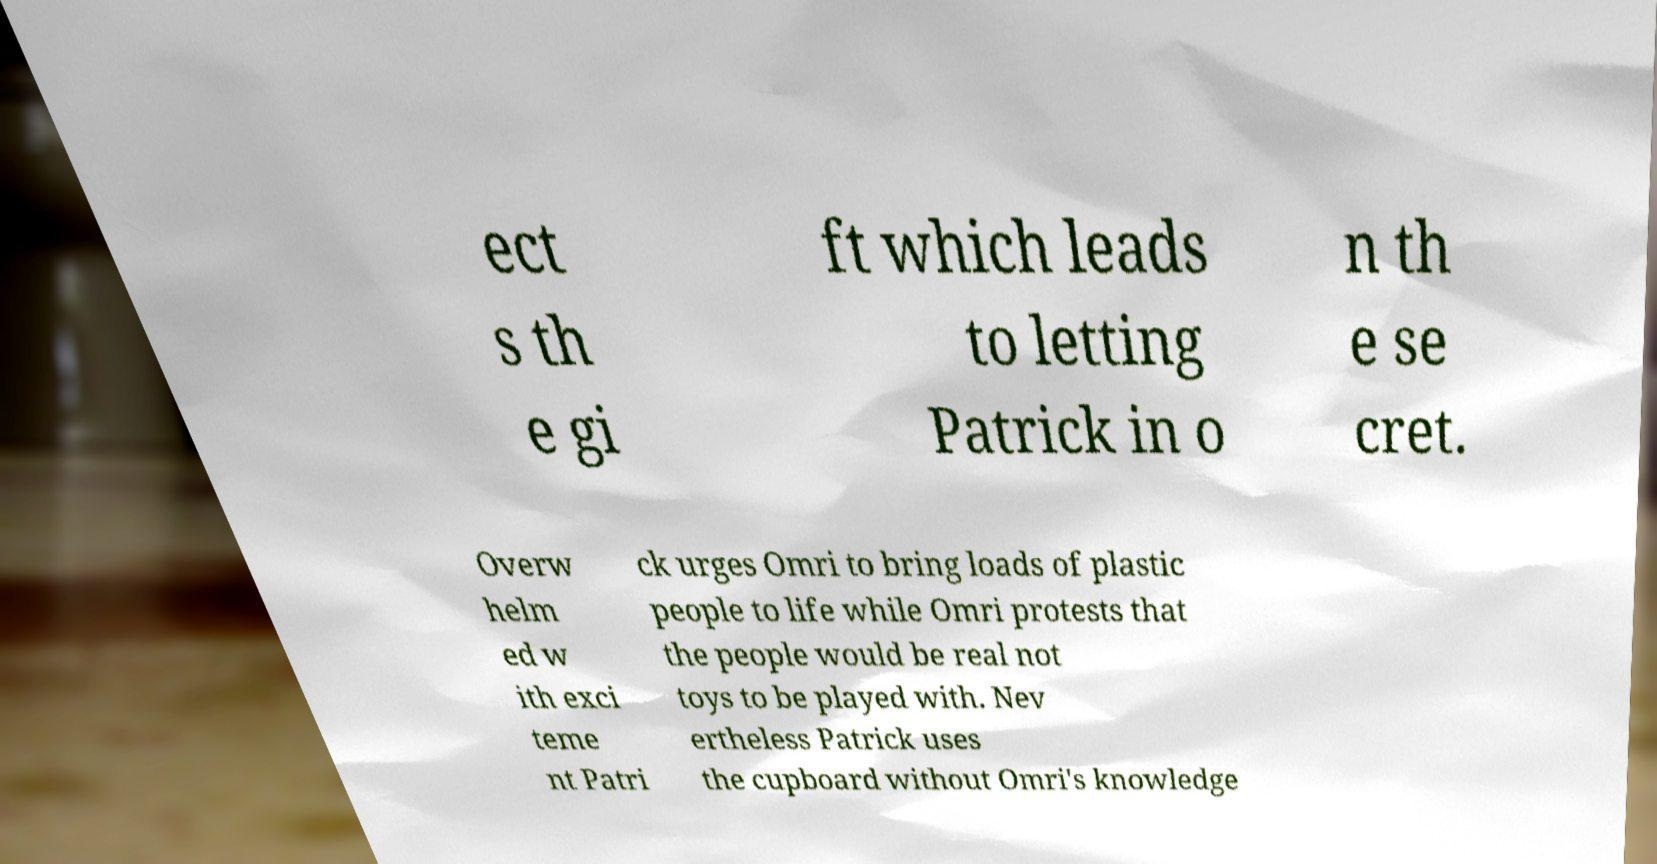What messages or text are displayed in this image? I need them in a readable, typed format. ect s th e gi ft which leads to letting Patrick in o n th e se cret. Overw helm ed w ith exci teme nt Patri ck urges Omri to bring loads of plastic people to life while Omri protests that the people would be real not toys to be played with. Nev ertheless Patrick uses the cupboard without Omri's knowledge 